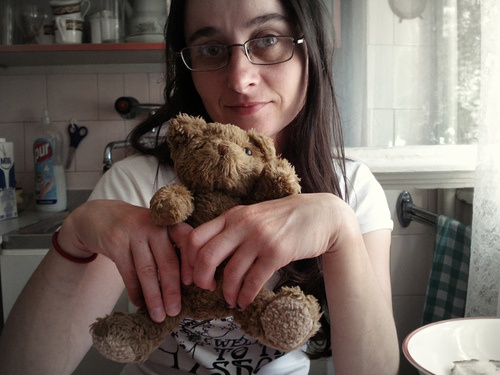Describe the objects in this image and their specific colors. I can see people in black, gray, and maroon tones, teddy bear in black, maroon, and gray tones, bowl in black, ivory, darkgray, and lightgray tones, bottle in black and gray tones, and cup in black and gray tones in this image. 